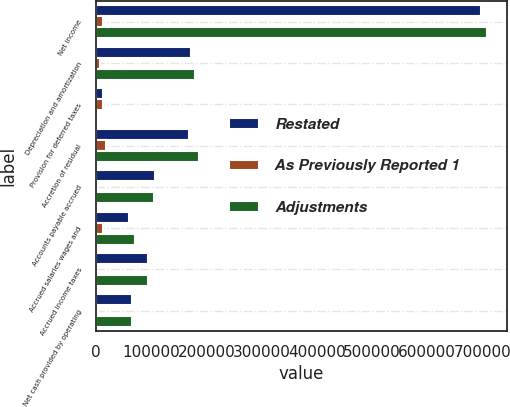Convert chart to OTSL. <chart><loc_0><loc_0><loc_500><loc_500><stacked_bar_chart><ecel><fcel>Net income<fcel>Depreciation and amortization<fcel>Provision for deferred taxes<fcel>Accretion of residual<fcel>Accounts payable accrued<fcel>Accrued salaries wages and<fcel>Accrued income taxes<fcel>Net cash provided by operating<nl><fcel>Restated<fcel>697897<fcel>172038<fcel>11459<fcel>168030<fcel>105737<fcel>58468<fcel>93710<fcel>64494.5<nl><fcel>As Previously Reported 1<fcel>11352<fcel>7093<fcel>12445<fcel>18436<fcel>1174<fcel>12053<fcel>60<fcel>3747<nl><fcel>Adjustments<fcel>709249<fcel>179131<fcel>986<fcel>186466<fcel>104563<fcel>70521<fcel>93770<fcel>64494.5<nl></chart> 